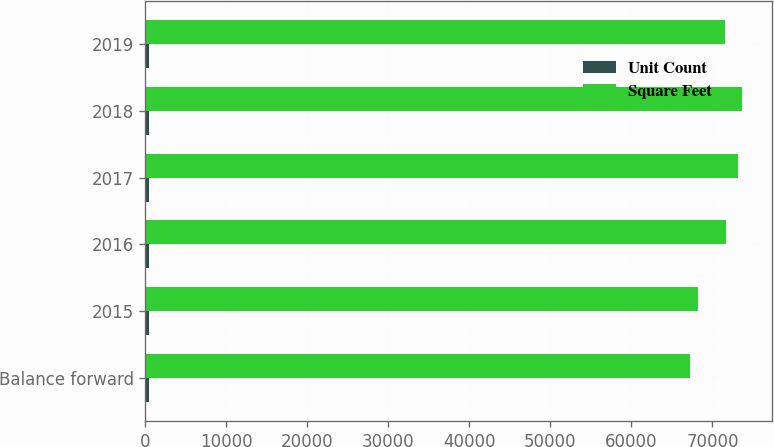Convert chart. <chart><loc_0><loc_0><loc_500><loc_500><stacked_bar_chart><ecel><fcel>Balance forward<fcel>2015<fcel>2016<fcel>2017<fcel>2018<fcel>2019<nl><fcel>Unit Count<fcel>405<fcel>411<fcel>432<fcel>439<fcel>443<fcel>443<nl><fcel>Square Feet<fcel>67205<fcel>68269<fcel>71724<fcel>73172<fcel>73615<fcel>71543<nl></chart> 